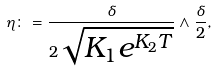Convert formula to latex. <formula><loc_0><loc_0><loc_500><loc_500>\eta \colon = \frac { \delta } { 2 \sqrt { K _ { 1 } e ^ { K _ { 2 } T } } } \wedge \frac { \delta } { 2 } ,</formula> 